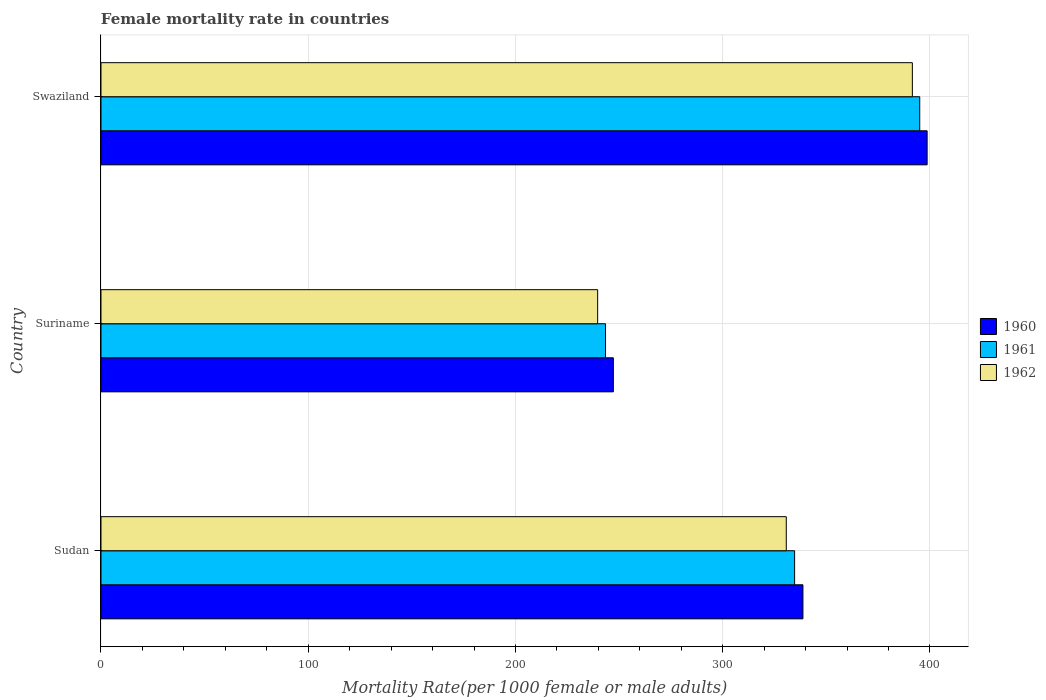How many different coloured bars are there?
Your answer should be very brief. 3. Are the number of bars per tick equal to the number of legend labels?
Your response must be concise. Yes. How many bars are there on the 1st tick from the bottom?
Make the answer very short. 3. What is the label of the 2nd group of bars from the top?
Your response must be concise. Suriname. In how many cases, is the number of bars for a given country not equal to the number of legend labels?
Your response must be concise. 0. What is the female mortality rate in 1962 in Sudan?
Provide a succinct answer. 330.69. Across all countries, what is the maximum female mortality rate in 1962?
Your answer should be very brief. 391.53. Across all countries, what is the minimum female mortality rate in 1962?
Your answer should be very brief. 239.67. In which country was the female mortality rate in 1960 maximum?
Your answer should be compact. Swaziland. In which country was the female mortality rate in 1961 minimum?
Your response must be concise. Suriname. What is the total female mortality rate in 1961 in the graph?
Your answer should be compact. 973.26. What is the difference between the female mortality rate in 1960 in Sudan and that in Suriname?
Offer a terse response. 91.49. What is the difference between the female mortality rate in 1960 in Sudan and the female mortality rate in 1962 in Swaziland?
Offer a very short reply. -52.8. What is the average female mortality rate in 1962 per country?
Make the answer very short. 320.63. What is the difference between the female mortality rate in 1960 and female mortality rate in 1961 in Sudan?
Provide a short and direct response. 4.02. In how many countries, is the female mortality rate in 1962 greater than 240 ?
Your answer should be very brief. 2. What is the ratio of the female mortality rate in 1962 in Sudan to that in Swaziland?
Give a very brief answer. 0.84. Is the difference between the female mortality rate in 1960 in Sudan and Suriname greater than the difference between the female mortality rate in 1961 in Sudan and Suriname?
Provide a short and direct response. Yes. What is the difference between the highest and the second highest female mortality rate in 1962?
Offer a terse response. 60.84. What is the difference between the highest and the lowest female mortality rate in 1960?
Your answer should be compact. 151.41. Is the sum of the female mortality rate in 1960 in Sudan and Swaziland greater than the maximum female mortality rate in 1961 across all countries?
Your response must be concise. Yes. What does the 3rd bar from the top in Sudan represents?
Offer a very short reply. 1960. Is it the case that in every country, the sum of the female mortality rate in 1962 and female mortality rate in 1961 is greater than the female mortality rate in 1960?
Offer a very short reply. Yes. Are the values on the major ticks of X-axis written in scientific E-notation?
Offer a terse response. No. Does the graph contain any zero values?
Provide a short and direct response. No. How are the legend labels stacked?
Give a very brief answer. Vertical. What is the title of the graph?
Give a very brief answer. Female mortality rate in countries. Does "1979" appear as one of the legend labels in the graph?
Offer a very short reply. No. What is the label or title of the X-axis?
Provide a succinct answer. Mortality Rate(per 1000 female or male adults). What is the label or title of the Y-axis?
Keep it short and to the point. Country. What is the Mortality Rate(per 1000 female or male adults) of 1960 in Sudan?
Offer a very short reply. 338.73. What is the Mortality Rate(per 1000 female or male adults) of 1961 in Sudan?
Your response must be concise. 334.71. What is the Mortality Rate(per 1000 female or male adults) of 1962 in Sudan?
Your response must be concise. 330.69. What is the Mortality Rate(per 1000 female or male adults) of 1960 in Suriname?
Your answer should be very brief. 247.24. What is the Mortality Rate(per 1000 female or male adults) of 1961 in Suriname?
Provide a short and direct response. 243.46. What is the Mortality Rate(per 1000 female or male adults) in 1962 in Suriname?
Provide a short and direct response. 239.67. What is the Mortality Rate(per 1000 female or male adults) of 1960 in Swaziland?
Ensure brevity in your answer.  398.66. What is the Mortality Rate(per 1000 female or male adults) in 1961 in Swaziland?
Keep it short and to the point. 395.1. What is the Mortality Rate(per 1000 female or male adults) in 1962 in Swaziland?
Provide a short and direct response. 391.53. Across all countries, what is the maximum Mortality Rate(per 1000 female or male adults) of 1960?
Give a very brief answer. 398.66. Across all countries, what is the maximum Mortality Rate(per 1000 female or male adults) in 1961?
Provide a short and direct response. 395.1. Across all countries, what is the maximum Mortality Rate(per 1000 female or male adults) in 1962?
Keep it short and to the point. 391.53. Across all countries, what is the minimum Mortality Rate(per 1000 female or male adults) in 1960?
Ensure brevity in your answer.  247.24. Across all countries, what is the minimum Mortality Rate(per 1000 female or male adults) of 1961?
Provide a short and direct response. 243.46. Across all countries, what is the minimum Mortality Rate(per 1000 female or male adults) in 1962?
Give a very brief answer. 239.67. What is the total Mortality Rate(per 1000 female or male adults) in 1960 in the graph?
Your answer should be very brief. 984.63. What is the total Mortality Rate(per 1000 female or male adults) of 1961 in the graph?
Your answer should be very brief. 973.26. What is the total Mortality Rate(per 1000 female or male adults) in 1962 in the graph?
Ensure brevity in your answer.  961.9. What is the difference between the Mortality Rate(per 1000 female or male adults) in 1960 in Sudan and that in Suriname?
Provide a short and direct response. 91.49. What is the difference between the Mortality Rate(per 1000 female or male adults) in 1961 in Sudan and that in Suriname?
Give a very brief answer. 91.25. What is the difference between the Mortality Rate(per 1000 female or male adults) in 1962 in Sudan and that in Suriname?
Your response must be concise. 91.02. What is the difference between the Mortality Rate(per 1000 female or male adults) in 1960 in Sudan and that in Swaziland?
Make the answer very short. -59.93. What is the difference between the Mortality Rate(per 1000 female or male adults) in 1961 in Sudan and that in Swaziland?
Keep it short and to the point. -60.38. What is the difference between the Mortality Rate(per 1000 female or male adults) of 1962 in Sudan and that in Swaziland?
Your response must be concise. -60.84. What is the difference between the Mortality Rate(per 1000 female or male adults) of 1960 in Suriname and that in Swaziland?
Make the answer very short. -151.41. What is the difference between the Mortality Rate(per 1000 female or male adults) of 1961 in Suriname and that in Swaziland?
Ensure brevity in your answer.  -151.64. What is the difference between the Mortality Rate(per 1000 female or male adults) in 1962 in Suriname and that in Swaziland?
Ensure brevity in your answer.  -151.86. What is the difference between the Mortality Rate(per 1000 female or male adults) in 1960 in Sudan and the Mortality Rate(per 1000 female or male adults) in 1961 in Suriname?
Ensure brevity in your answer.  95.27. What is the difference between the Mortality Rate(per 1000 female or male adults) in 1960 in Sudan and the Mortality Rate(per 1000 female or male adults) in 1962 in Suriname?
Keep it short and to the point. 99.06. What is the difference between the Mortality Rate(per 1000 female or male adults) of 1961 in Sudan and the Mortality Rate(per 1000 female or male adults) of 1962 in Suriname?
Provide a succinct answer. 95.04. What is the difference between the Mortality Rate(per 1000 female or male adults) of 1960 in Sudan and the Mortality Rate(per 1000 female or male adults) of 1961 in Swaziland?
Keep it short and to the point. -56.37. What is the difference between the Mortality Rate(per 1000 female or male adults) in 1960 in Sudan and the Mortality Rate(per 1000 female or male adults) in 1962 in Swaziland?
Your response must be concise. -52.8. What is the difference between the Mortality Rate(per 1000 female or male adults) of 1961 in Sudan and the Mortality Rate(per 1000 female or male adults) of 1962 in Swaziland?
Your answer should be compact. -56.82. What is the difference between the Mortality Rate(per 1000 female or male adults) of 1960 in Suriname and the Mortality Rate(per 1000 female or male adults) of 1961 in Swaziland?
Offer a very short reply. -147.85. What is the difference between the Mortality Rate(per 1000 female or male adults) of 1960 in Suriname and the Mortality Rate(per 1000 female or male adults) of 1962 in Swaziland?
Give a very brief answer. -144.29. What is the difference between the Mortality Rate(per 1000 female or male adults) of 1961 in Suriname and the Mortality Rate(per 1000 female or male adults) of 1962 in Swaziland?
Give a very brief answer. -148.08. What is the average Mortality Rate(per 1000 female or male adults) of 1960 per country?
Offer a very short reply. 328.21. What is the average Mortality Rate(per 1000 female or male adults) in 1961 per country?
Keep it short and to the point. 324.42. What is the average Mortality Rate(per 1000 female or male adults) in 1962 per country?
Provide a short and direct response. 320.63. What is the difference between the Mortality Rate(per 1000 female or male adults) of 1960 and Mortality Rate(per 1000 female or male adults) of 1961 in Sudan?
Your response must be concise. 4.02. What is the difference between the Mortality Rate(per 1000 female or male adults) in 1960 and Mortality Rate(per 1000 female or male adults) in 1962 in Sudan?
Your answer should be very brief. 8.03. What is the difference between the Mortality Rate(per 1000 female or male adults) in 1961 and Mortality Rate(per 1000 female or male adults) in 1962 in Sudan?
Offer a terse response. 4.02. What is the difference between the Mortality Rate(per 1000 female or male adults) in 1960 and Mortality Rate(per 1000 female or male adults) in 1961 in Suriname?
Keep it short and to the point. 3.79. What is the difference between the Mortality Rate(per 1000 female or male adults) in 1960 and Mortality Rate(per 1000 female or male adults) in 1962 in Suriname?
Keep it short and to the point. 7.57. What is the difference between the Mortality Rate(per 1000 female or male adults) in 1961 and Mortality Rate(per 1000 female or male adults) in 1962 in Suriname?
Ensure brevity in your answer.  3.79. What is the difference between the Mortality Rate(per 1000 female or male adults) of 1960 and Mortality Rate(per 1000 female or male adults) of 1961 in Swaziland?
Ensure brevity in your answer.  3.56. What is the difference between the Mortality Rate(per 1000 female or male adults) of 1960 and Mortality Rate(per 1000 female or male adults) of 1962 in Swaziland?
Provide a succinct answer. 7.12. What is the difference between the Mortality Rate(per 1000 female or male adults) in 1961 and Mortality Rate(per 1000 female or male adults) in 1962 in Swaziland?
Provide a succinct answer. 3.56. What is the ratio of the Mortality Rate(per 1000 female or male adults) in 1960 in Sudan to that in Suriname?
Make the answer very short. 1.37. What is the ratio of the Mortality Rate(per 1000 female or male adults) of 1961 in Sudan to that in Suriname?
Keep it short and to the point. 1.37. What is the ratio of the Mortality Rate(per 1000 female or male adults) of 1962 in Sudan to that in Suriname?
Offer a terse response. 1.38. What is the ratio of the Mortality Rate(per 1000 female or male adults) in 1960 in Sudan to that in Swaziland?
Your answer should be very brief. 0.85. What is the ratio of the Mortality Rate(per 1000 female or male adults) of 1961 in Sudan to that in Swaziland?
Your answer should be very brief. 0.85. What is the ratio of the Mortality Rate(per 1000 female or male adults) in 1962 in Sudan to that in Swaziland?
Your answer should be very brief. 0.84. What is the ratio of the Mortality Rate(per 1000 female or male adults) of 1960 in Suriname to that in Swaziland?
Make the answer very short. 0.62. What is the ratio of the Mortality Rate(per 1000 female or male adults) of 1961 in Suriname to that in Swaziland?
Ensure brevity in your answer.  0.62. What is the ratio of the Mortality Rate(per 1000 female or male adults) of 1962 in Suriname to that in Swaziland?
Ensure brevity in your answer.  0.61. What is the difference between the highest and the second highest Mortality Rate(per 1000 female or male adults) of 1960?
Keep it short and to the point. 59.93. What is the difference between the highest and the second highest Mortality Rate(per 1000 female or male adults) in 1961?
Provide a short and direct response. 60.38. What is the difference between the highest and the second highest Mortality Rate(per 1000 female or male adults) of 1962?
Make the answer very short. 60.84. What is the difference between the highest and the lowest Mortality Rate(per 1000 female or male adults) of 1960?
Keep it short and to the point. 151.41. What is the difference between the highest and the lowest Mortality Rate(per 1000 female or male adults) in 1961?
Offer a terse response. 151.64. What is the difference between the highest and the lowest Mortality Rate(per 1000 female or male adults) of 1962?
Provide a succinct answer. 151.86. 